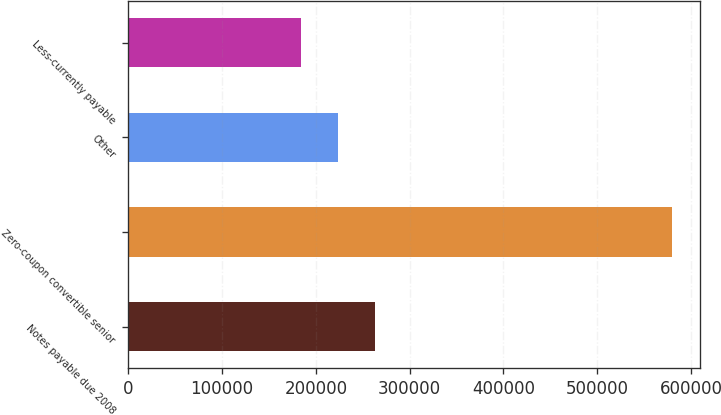Convert chart. <chart><loc_0><loc_0><loc_500><loc_500><bar_chart><fcel>Notes payable due 2008<fcel>Zero-coupon convertible senior<fcel>Other<fcel>Less-currently payable<nl><fcel>263236<fcel>580375<fcel>223593<fcel>183951<nl></chart> 